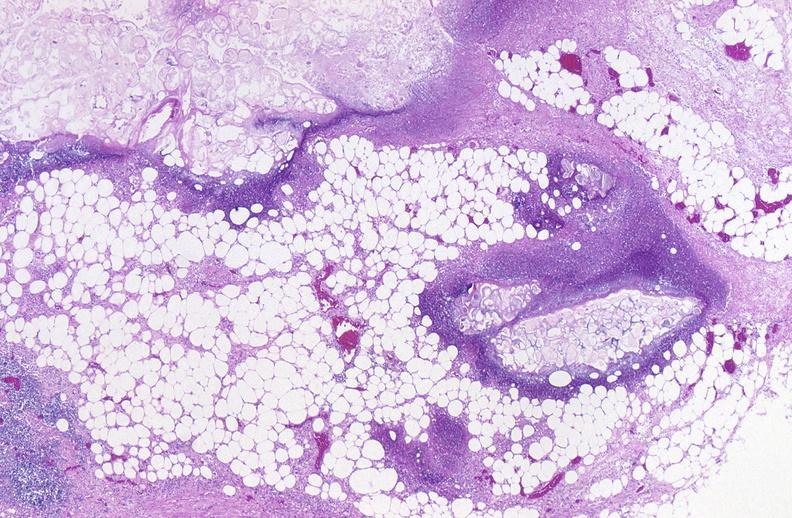where is this?
Answer the question using a single word or phrase. Pancreas 